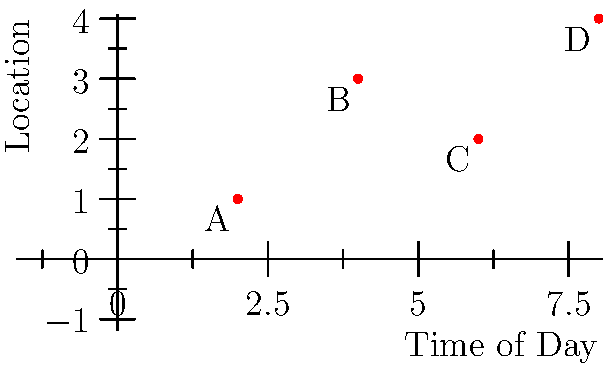You've observed suspicious activities at different locations in your workplace throughout the day. The x-axis represents the time of day (in hours since 8 AM), and the y-axis represents different locations (1 = Lobby, 2 = Office, 3 = Storage, 4 = Server Room). Which location has the most suspicious activity reported, and at what time did the latest suspicious activity occur? To answer this question, we need to analyze the given coordinate system:

1. First, let's identify the locations of each point:
   Point A: (2, 1) - Lobby at 10 AM
   Point B: (4, 3) - Storage at 12 PM
   Point C: (6, 2) - Office at 2 PM
   Point D: (8, 4) - Server Room at 4 PM

2. To determine which location has the most suspicious activity:
   Lobby (y=1): 1 instance
   Office (y=2): 1 instance
   Storage (y=3): 1 instance
   Server Room (y=4): 1 instance

   All locations have one instance of suspicious activity, so there's no single location with the most activity.

3. To find the latest suspicious activity:
   Compare the x-coordinates (time) of all points.
   The largest x-coordinate is 8, corresponding to Point D.

4. Point D is at (8, 4), which represents:
   Time: 8 hours after 8 AM = 4 PM
   Location: y=4, which is the Server Room

Therefore, the latest suspicious activity occurred in the Server Room at 4 PM.
Answer: Server Room, 4 PM 